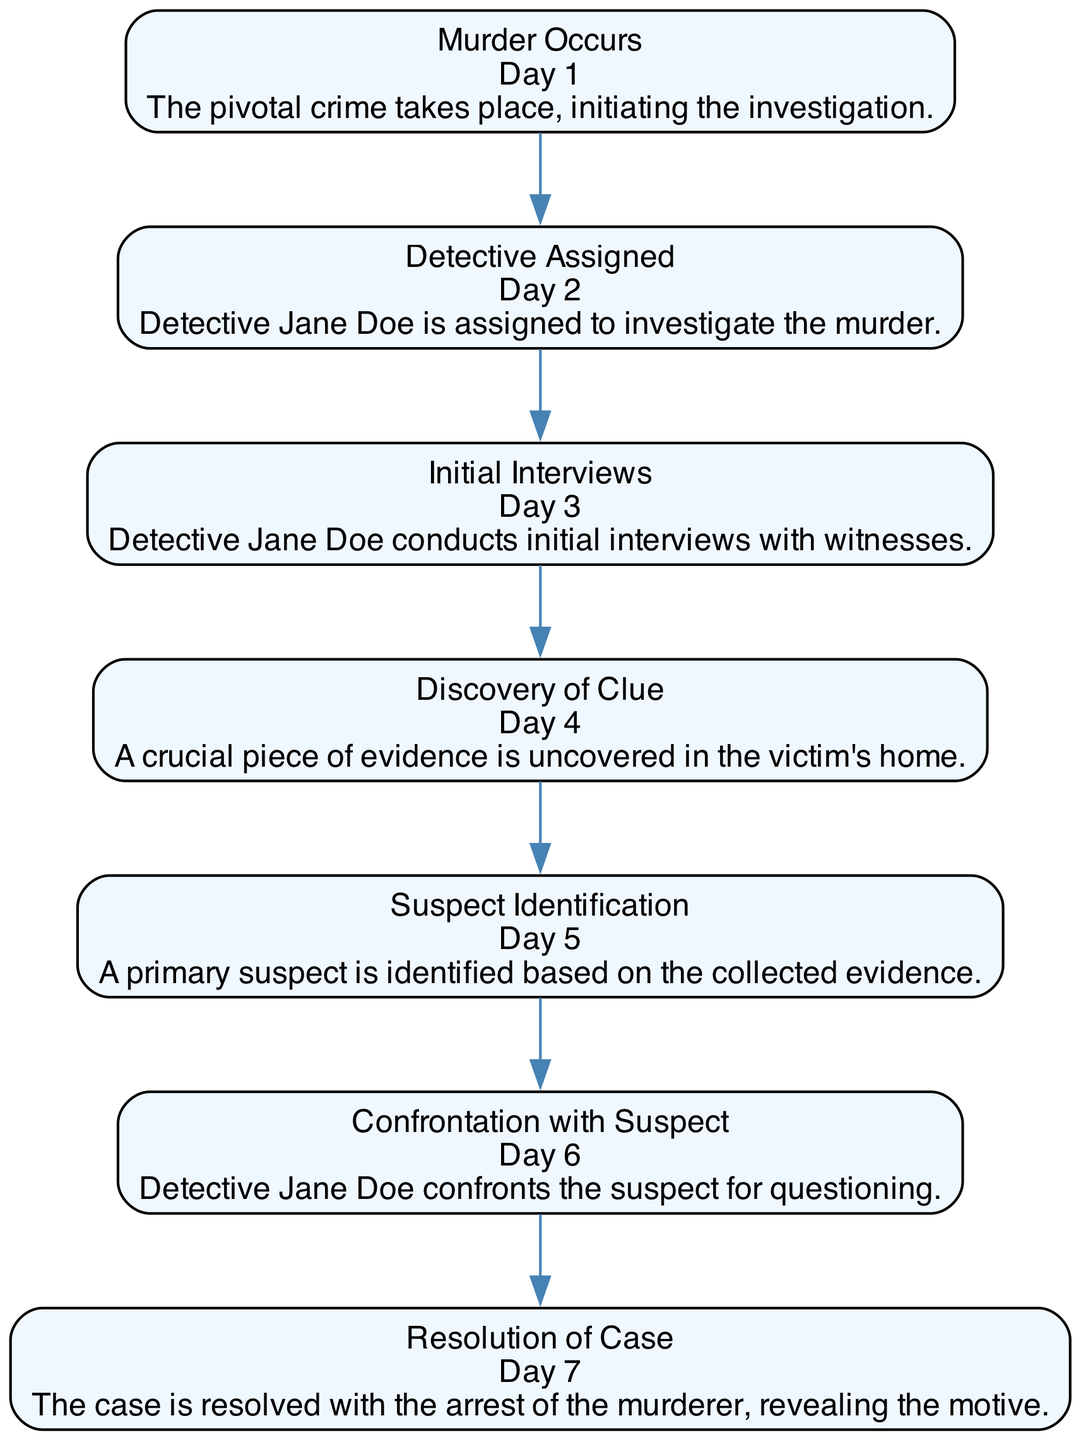What event occurs on Day 1? The diagram specifies that the first event is "Murder Occurs," which is denoted at the top of the sequence and aligns with the timestamp of Day 1.
Answer: Murder Occurs How many days does it take from the murder to the resolution? The diagram shows that the timeline spans from Day 1 when the murder occurs to Day 7 when the case is resolved, indicating a total of 6 days for the events to unfold.
Answer: 6 What is the last event in the sequence? The last element in the diagram is "Resolution of Case," which is placed at the end of the flow and denotes the final conclusion of the timeline.
Answer: Resolution of Case Who is the detective assigned on Day 2? The sequence shows that Detective Jane Doe is assigned on Day 2, as indicated in the description of the event following the murder.
Answer: Detective Jane Doe What event follows the "Suspect Identification"? By following the sequence in the diagram, the event directly after "Suspect Identification" is "Confrontation with Suspect," indicating the actions taken after identifying a suspect.
Answer: Confrontation with Suspect How many total events are depicted in this diagram? The diagram lists a total of 7 distinct events, starting from "Murder Occurs" and concluding with "Resolution of Case."
Answer: 7 What evidence is discovered on Day 4? According to the diagram, a "Discovery of Clue" is the specific evidence mentioned that is uncovered in the victim's home on Day 4.
Answer: Discovery of Clue Which event is the initial step in the investigation after the murder? The diagram indicates that "Detective Assigned" is the first step taken after the murder occurs, occurring on Day 2.
Answer: Detective Assigned What does the "Resolution of Case" reveal? The last event mentions that the resolution reveals the motive behind the murder, summarizing the conclusion of the investigation.
Answer: Revealing the motive 